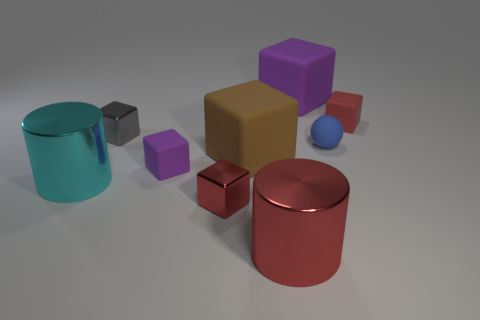Subtract all red rubber blocks. How many blocks are left? 5 Add 1 small red metallic cylinders. How many objects exist? 10 Subtract all purple blocks. How many blocks are left? 4 Subtract 4 cubes. How many cubes are left? 2 Subtract all green spheres. How many red blocks are left? 2 Subtract all cubes. How many objects are left? 3 Add 9 small blue things. How many small blue things exist? 10 Subtract 0 blue cylinders. How many objects are left? 9 Subtract all brown blocks. Subtract all red spheres. How many blocks are left? 5 Subtract all big red objects. Subtract all large metallic spheres. How many objects are left? 8 